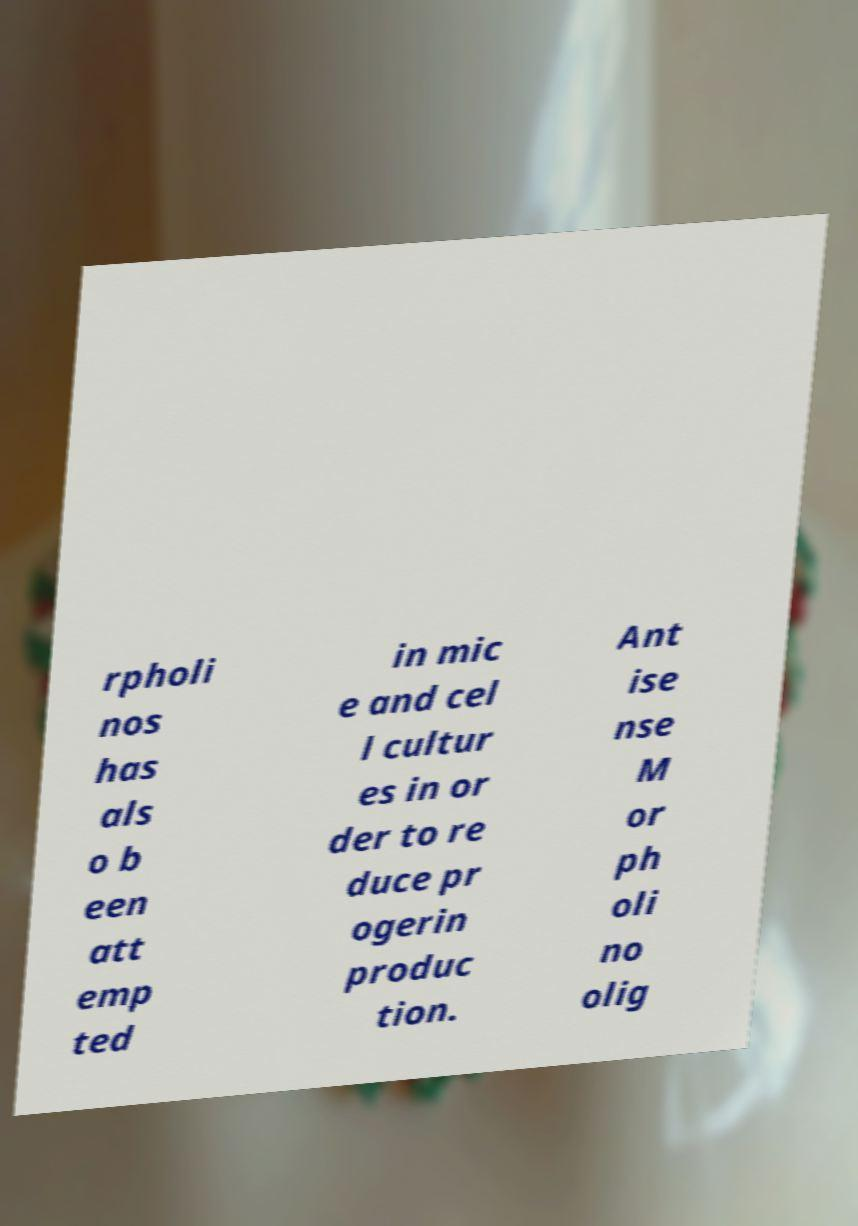Please read and relay the text visible in this image. What does it say? rpholi nos has als o b een att emp ted in mic e and cel l cultur es in or der to re duce pr ogerin produc tion. Ant ise nse M or ph oli no olig 